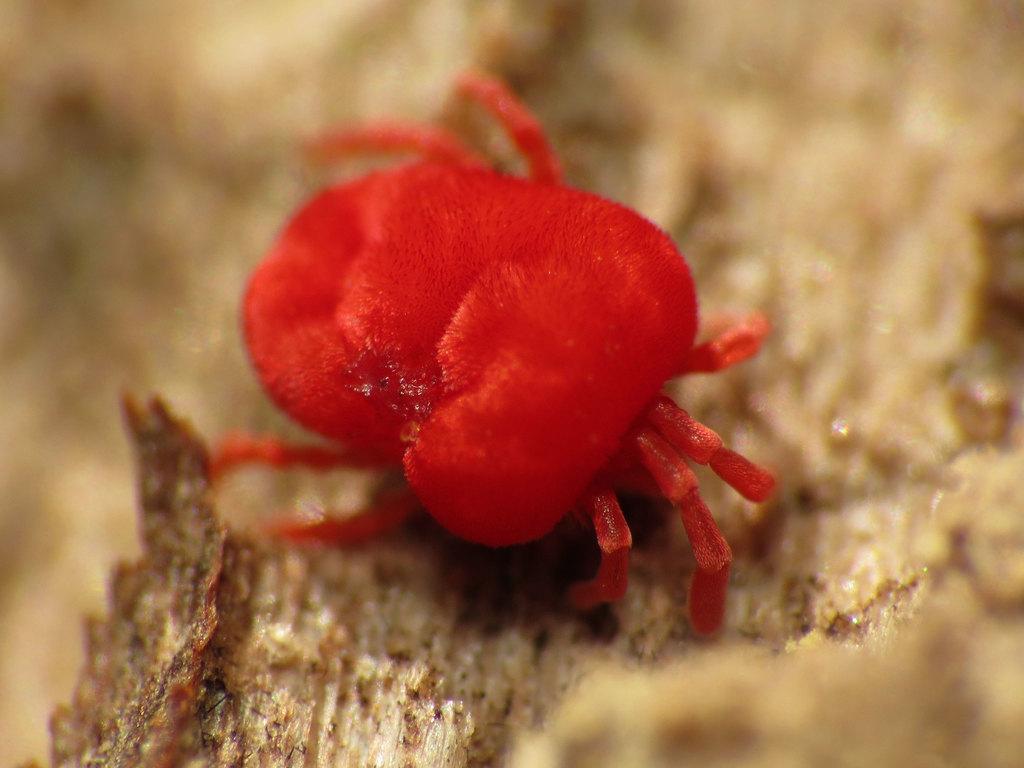Could you give a brief overview of what you see in this image? In this picture we can see a red color insect on a platform and in the background it is blurry. 